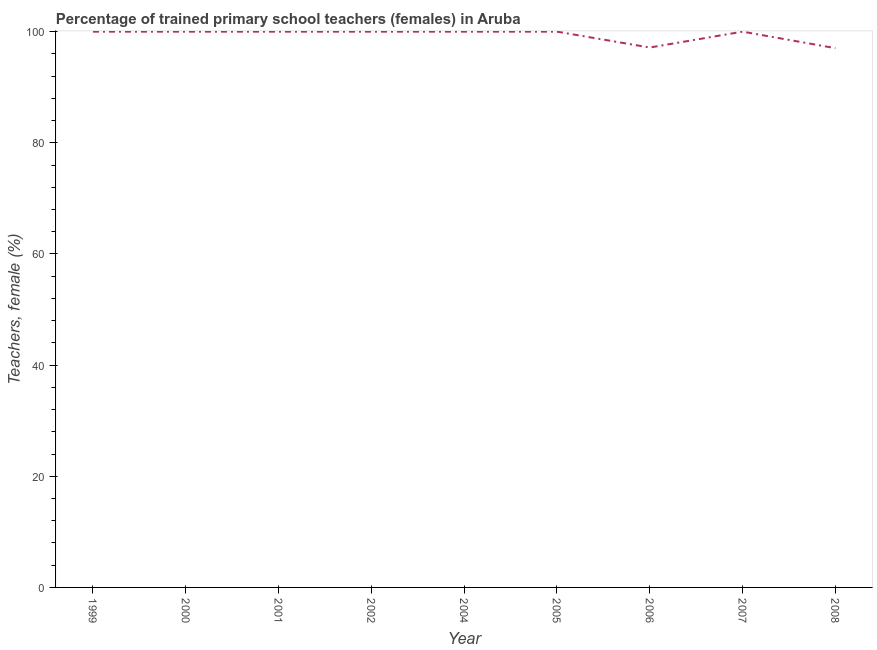What is the percentage of trained female teachers in 2007?
Offer a terse response. 100. Across all years, what is the minimum percentage of trained female teachers?
Offer a very short reply. 97.03. In which year was the percentage of trained female teachers maximum?
Provide a short and direct response. 1999. In which year was the percentage of trained female teachers minimum?
Ensure brevity in your answer.  2008. What is the sum of the percentage of trained female teachers?
Keep it short and to the point. 894.17. What is the difference between the percentage of trained female teachers in 2000 and 2006?
Provide a short and direct response. 2.86. What is the average percentage of trained female teachers per year?
Give a very brief answer. 99.35. What is the ratio of the percentage of trained female teachers in 2004 to that in 2008?
Your answer should be very brief. 1.03. Is the percentage of trained female teachers in 1999 less than that in 2000?
Your answer should be compact. No. Is the difference between the percentage of trained female teachers in 2002 and 2005 greater than the difference between any two years?
Your answer should be very brief. No. What is the difference between the highest and the lowest percentage of trained female teachers?
Keep it short and to the point. 2.97. In how many years, is the percentage of trained female teachers greater than the average percentage of trained female teachers taken over all years?
Provide a succinct answer. 7. What is the difference between two consecutive major ticks on the Y-axis?
Keep it short and to the point. 20. Does the graph contain any zero values?
Keep it short and to the point. No. Does the graph contain grids?
Keep it short and to the point. No. What is the title of the graph?
Keep it short and to the point. Percentage of trained primary school teachers (females) in Aruba. What is the label or title of the Y-axis?
Provide a succinct answer. Teachers, female (%). What is the Teachers, female (%) of 1999?
Offer a very short reply. 100. What is the Teachers, female (%) in 2001?
Offer a very short reply. 100. What is the Teachers, female (%) in 2002?
Provide a succinct answer. 100. What is the Teachers, female (%) in 2004?
Keep it short and to the point. 100. What is the Teachers, female (%) in 2006?
Ensure brevity in your answer.  97.14. What is the Teachers, female (%) of 2007?
Provide a succinct answer. 100. What is the Teachers, female (%) of 2008?
Offer a very short reply. 97.03. What is the difference between the Teachers, female (%) in 1999 and 2002?
Make the answer very short. 0. What is the difference between the Teachers, female (%) in 1999 and 2005?
Give a very brief answer. 0. What is the difference between the Teachers, female (%) in 1999 and 2006?
Provide a succinct answer. 2.86. What is the difference between the Teachers, female (%) in 1999 and 2007?
Your answer should be very brief. 0. What is the difference between the Teachers, female (%) in 1999 and 2008?
Provide a succinct answer. 2.97. What is the difference between the Teachers, female (%) in 2000 and 2001?
Provide a succinct answer. 0. What is the difference between the Teachers, female (%) in 2000 and 2006?
Offer a terse response. 2.86. What is the difference between the Teachers, female (%) in 2000 and 2008?
Your response must be concise. 2.97. What is the difference between the Teachers, female (%) in 2001 and 2004?
Your answer should be compact. 0. What is the difference between the Teachers, female (%) in 2001 and 2005?
Provide a succinct answer. 0. What is the difference between the Teachers, female (%) in 2001 and 2006?
Your answer should be very brief. 2.86. What is the difference between the Teachers, female (%) in 2001 and 2008?
Your answer should be compact. 2.97. What is the difference between the Teachers, female (%) in 2002 and 2004?
Make the answer very short. 0. What is the difference between the Teachers, female (%) in 2002 and 2005?
Provide a short and direct response. 0. What is the difference between the Teachers, female (%) in 2002 and 2006?
Provide a succinct answer. 2.86. What is the difference between the Teachers, female (%) in 2002 and 2008?
Ensure brevity in your answer.  2.97. What is the difference between the Teachers, female (%) in 2004 and 2005?
Make the answer very short. 0. What is the difference between the Teachers, female (%) in 2004 and 2006?
Your answer should be compact. 2.86. What is the difference between the Teachers, female (%) in 2004 and 2007?
Make the answer very short. 0. What is the difference between the Teachers, female (%) in 2004 and 2008?
Your answer should be compact. 2.97. What is the difference between the Teachers, female (%) in 2005 and 2006?
Offer a very short reply. 2.86. What is the difference between the Teachers, female (%) in 2005 and 2007?
Offer a terse response. 0. What is the difference between the Teachers, female (%) in 2005 and 2008?
Provide a succinct answer. 2.97. What is the difference between the Teachers, female (%) in 2006 and 2007?
Ensure brevity in your answer.  -2.86. What is the difference between the Teachers, female (%) in 2006 and 2008?
Offer a terse response. 0.11. What is the difference between the Teachers, female (%) in 2007 and 2008?
Ensure brevity in your answer.  2.97. What is the ratio of the Teachers, female (%) in 1999 to that in 2000?
Your response must be concise. 1. What is the ratio of the Teachers, female (%) in 1999 to that in 2002?
Your answer should be very brief. 1. What is the ratio of the Teachers, female (%) in 1999 to that in 2004?
Provide a succinct answer. 1. What is the ratio of the Teachers, female (%) in 1999 to that in 2006?
Provide a succinct answer. 1.03. What is the ratio of the Teachers, female (%) in 1999 to that in 2008?
Offer a terse response. 1.03. What is the ratio of the Teachers, female (%) in 2000 to that in 2004?
Offer a terse response. 1. What is the ratio of the Teachers, female (%) in 2000 to that in 2005?
Keep it short and to the point. 1. What is the ratio of the Teachers, female (%) in 2000 to that in 2006?
Ensure brevity in your answer.  1.03. What is the ratio of the Teachers, female (%) in 2000 to that in 2007?
Ensure brevity in your answer.  1. What is the ratio of the Teachers, female (%) in 2000 to that in 2008?
Make the answer very short. 1.03. What is the ratio of the Teachers, female (%) in 2001 to that in 2002?
Keep it short and to the point. 1. What is the ratio of the Teachers, female (%) in 2001 to that in 2004?
Keep it short and to the point. 1. What is the ratio of the Teachers, female (%) in 2001 to that in 2006?
Provide a short and direct response. 1.03. What is the ratio of the Teachers, female (%) in 2001 to that in 2008?
Make the answer very short. 1.03. What is the ratio of the Teachers, female (%) in 2002 to that in 2005?
Offer a very short reply. 1. What is the ratio of the Teachers, female (%) in 2002 to that in 2008?
Offer a very short reply. 1.03. What is the ratio of the Teachers, female (%) in 2004 to that in 2006?
Give a very brief answer. 1.03. What is the ratio of the Teachers, female (%) in 2004 to that in 2007?
Offer a terse response. 1. What is the ratio of the Teachers, female (%) in 2004 to that in 2008?
Your response must be concise. 1.03. What is the ratio of the Teachers, female (%) in 2005 to that in 2006?
Your answer should be very brief. 1.03. What is the ratio of the Teachers, female (%) in 2005 to that in 2008?
Your answer should be compact. 1.03. What is the ratio of the Teachers, female (%) in 2006 to that in 2007?
Your answer should be very brief. 0.97. What is the ratio of the Teachers, female (%) in 2007 to that in 2008?
Your response must be concise. 1.03. 